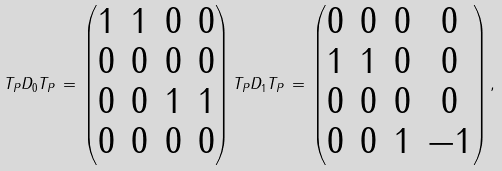<formula> <loc_0><loc_0><loc_500><loc_500>T _ { P } D _ { 0 } T _ { P } \, = \, \begin{pmatrix} 1 & 1 & 0 & 0 \\ 0 & 0 & 0 & 0 \\ 0 & 0 & 1 & 1 \\ 0 & 0 & 0 & 0 \end{pmatrix} T _ { P } D _ { 1 } T _ { P } \, = \, \begin{pmatrix} 0 & 0 & 0 & 0 \\ 1 & 1 & 0 & 0 \\ 0 & 0 & 0 & 0 \\ 0 & 0 & 1 & - 1 \end{pmatrix} ,</formula> 